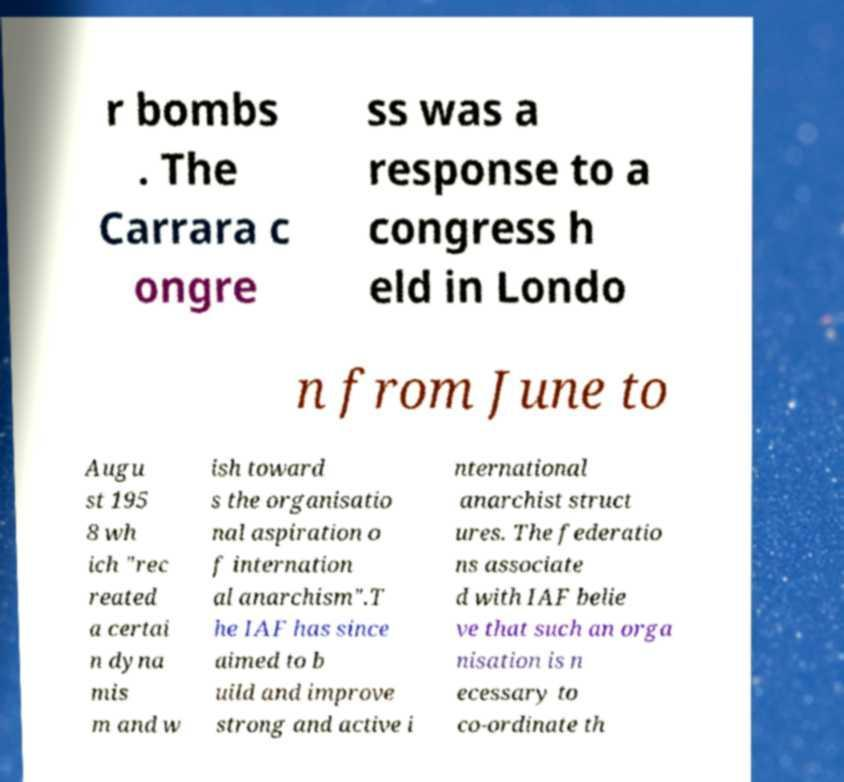I need the written content from this picture converted into text. Can you do that? r bombs . The Carrara c ongre ss was a response to a congress h eld in Londo n from June to Augu st 195 8 wh ich "rec reated a certai n dyna mis m and w ish toward s the organisatio nal aspiration o f internation al anarchism".T he IAF has since aimed to b uild and improve strong and active i nternational anarchist struct ures. The federatio ns associate d with IAF belie ve that such an orga nisation is n ecessary to co-ordinate th 